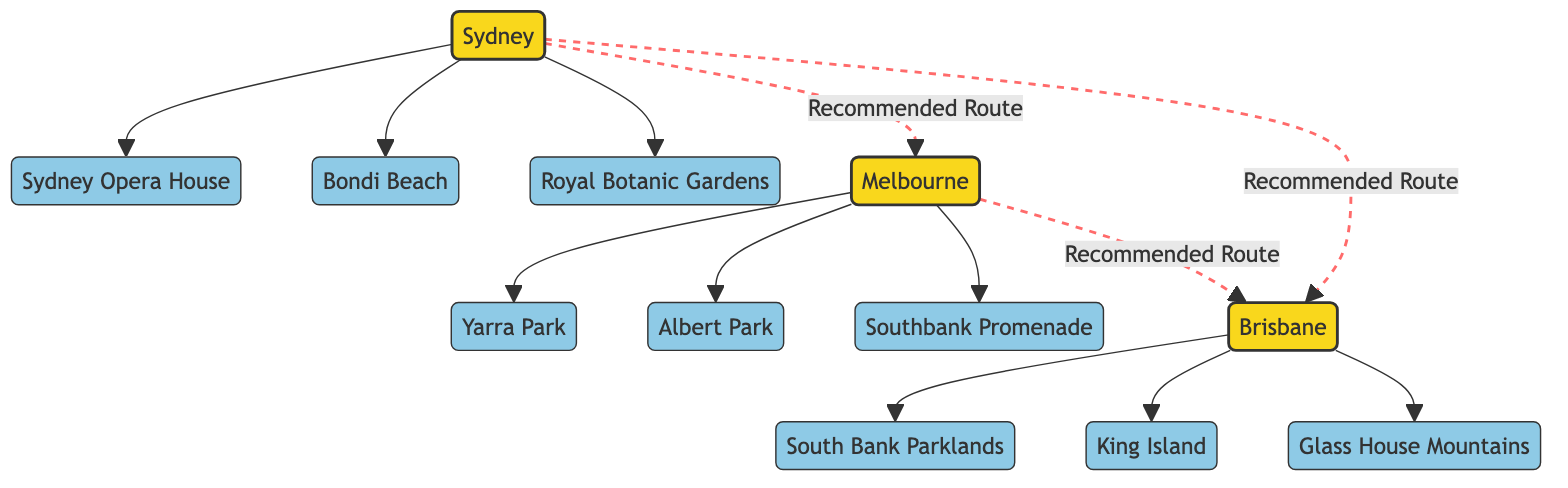What cities are represented in the diagram? The diagram consists of three cities: Sydney, Melbourne, and Brisbane. These are the primary nodes indicating major locations for dog-friendly travel in Australia.
Answer: Sydney, Melbourne, Brisbane How many landmarks are linked to Sydney? According to the diagram, Sydney has three linked landmarks: Sydney Opera House, Bondi Beach, and Royal Botanic Gardens. This is counted by identifying the edges connecting to the Sydney node.
Answer: 3 What is the recommended route from Sydney to Brisbane? The diagram indicates a direct recommended route from Sydney to Brisbane, which is shown as a dashed line connecting these two city nodes.
Answer: Direct Route Which landmark is associated with Melbourne? The landmarks linked to Melbourne in the diagram include Yarra Park, Albert Park, and Southbank Promenade. However, since the question asks for a single landmark, any of these can serve as an answer. I will choose Southbank Promenade, which is the last mentioned landmark linked to Melbourne.
Answer: Southbank Promenade How many total landmarks are in the diagram? There are a total of eight landmarks represented in the diagram: Sydney Opera House, Bondi Beach, Royal Botanic Gardens, Yarra Park, Albert Park, Southbank Promenade, South Bank Parklands, King Island, and Glass House Mountains. This was determined by counting all the unique landmark nodes connected to the cities.
Answer: 9 Which city connects to the highest number of landmarks? Sydney connects to three landmarks, while both Melbourne and Brisbane connect to three landmarks as well. Therefore, Sydney, Melbourne, and Brisbane all have the same highest number of landmarks.
Answer: Sydney, Melbourne, Brisbane Does Brisbane have a direct connection to South Bank Parklands? The diagram explicitly shows a direct connection (edge) from Brisbane to South Bank Parklands. This means they are directly linked as points of interest.
Answer: Yes What is the relationship between Sydney and Melbourne? The relationship between Sydney and Melbourne is established as a recommended travel route indicated by a dashed line connecting the two cities in the diagram.
Answer: Recommended Route 